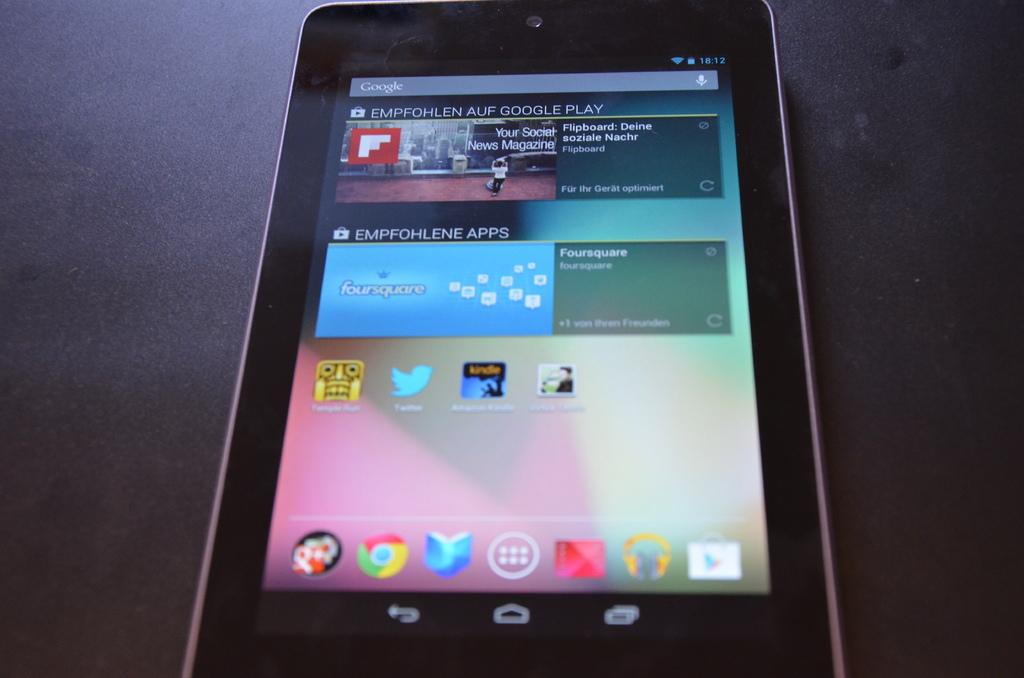What electronic device is visible in the image? There is a mobile phone in the image. What can be seen on the mobile phone's screen? The mobile phone has some apps visible on its screen. What is the color of the background in the image? The background of the image is dark in color. What type of flight is taking off in the background of the image? There is no flight present in the image; the background is dark in color. What type of cable is connected to the mobile phone in the image? There is no cable connected to the mobile phone in the image. 